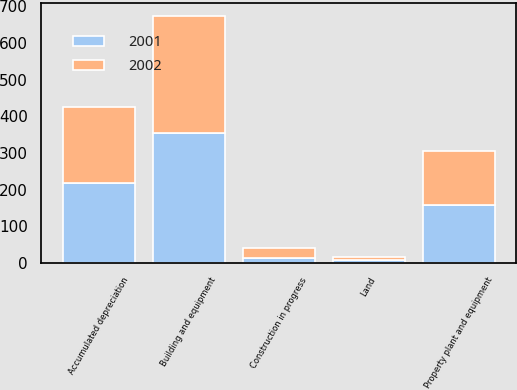<chart> <loc_0><loc_0><loc_500><loc_500><stacked_bar_chart><ecel><fcel>Land<fcel>Building and equipment<fcel>Construction in progress<fcel>Accumulated depreciation<fcel>Property plant and equipment<nl><fcel>2001<fcel>8.2<fcel>354.4<fcel>13.3<fcel>218.1<fcel>157.8<nl><fcel>2002<fcel>8<fcel>320.3<fcel>27.8<fcel>207.9<fcel>148.2<nl></chart> 